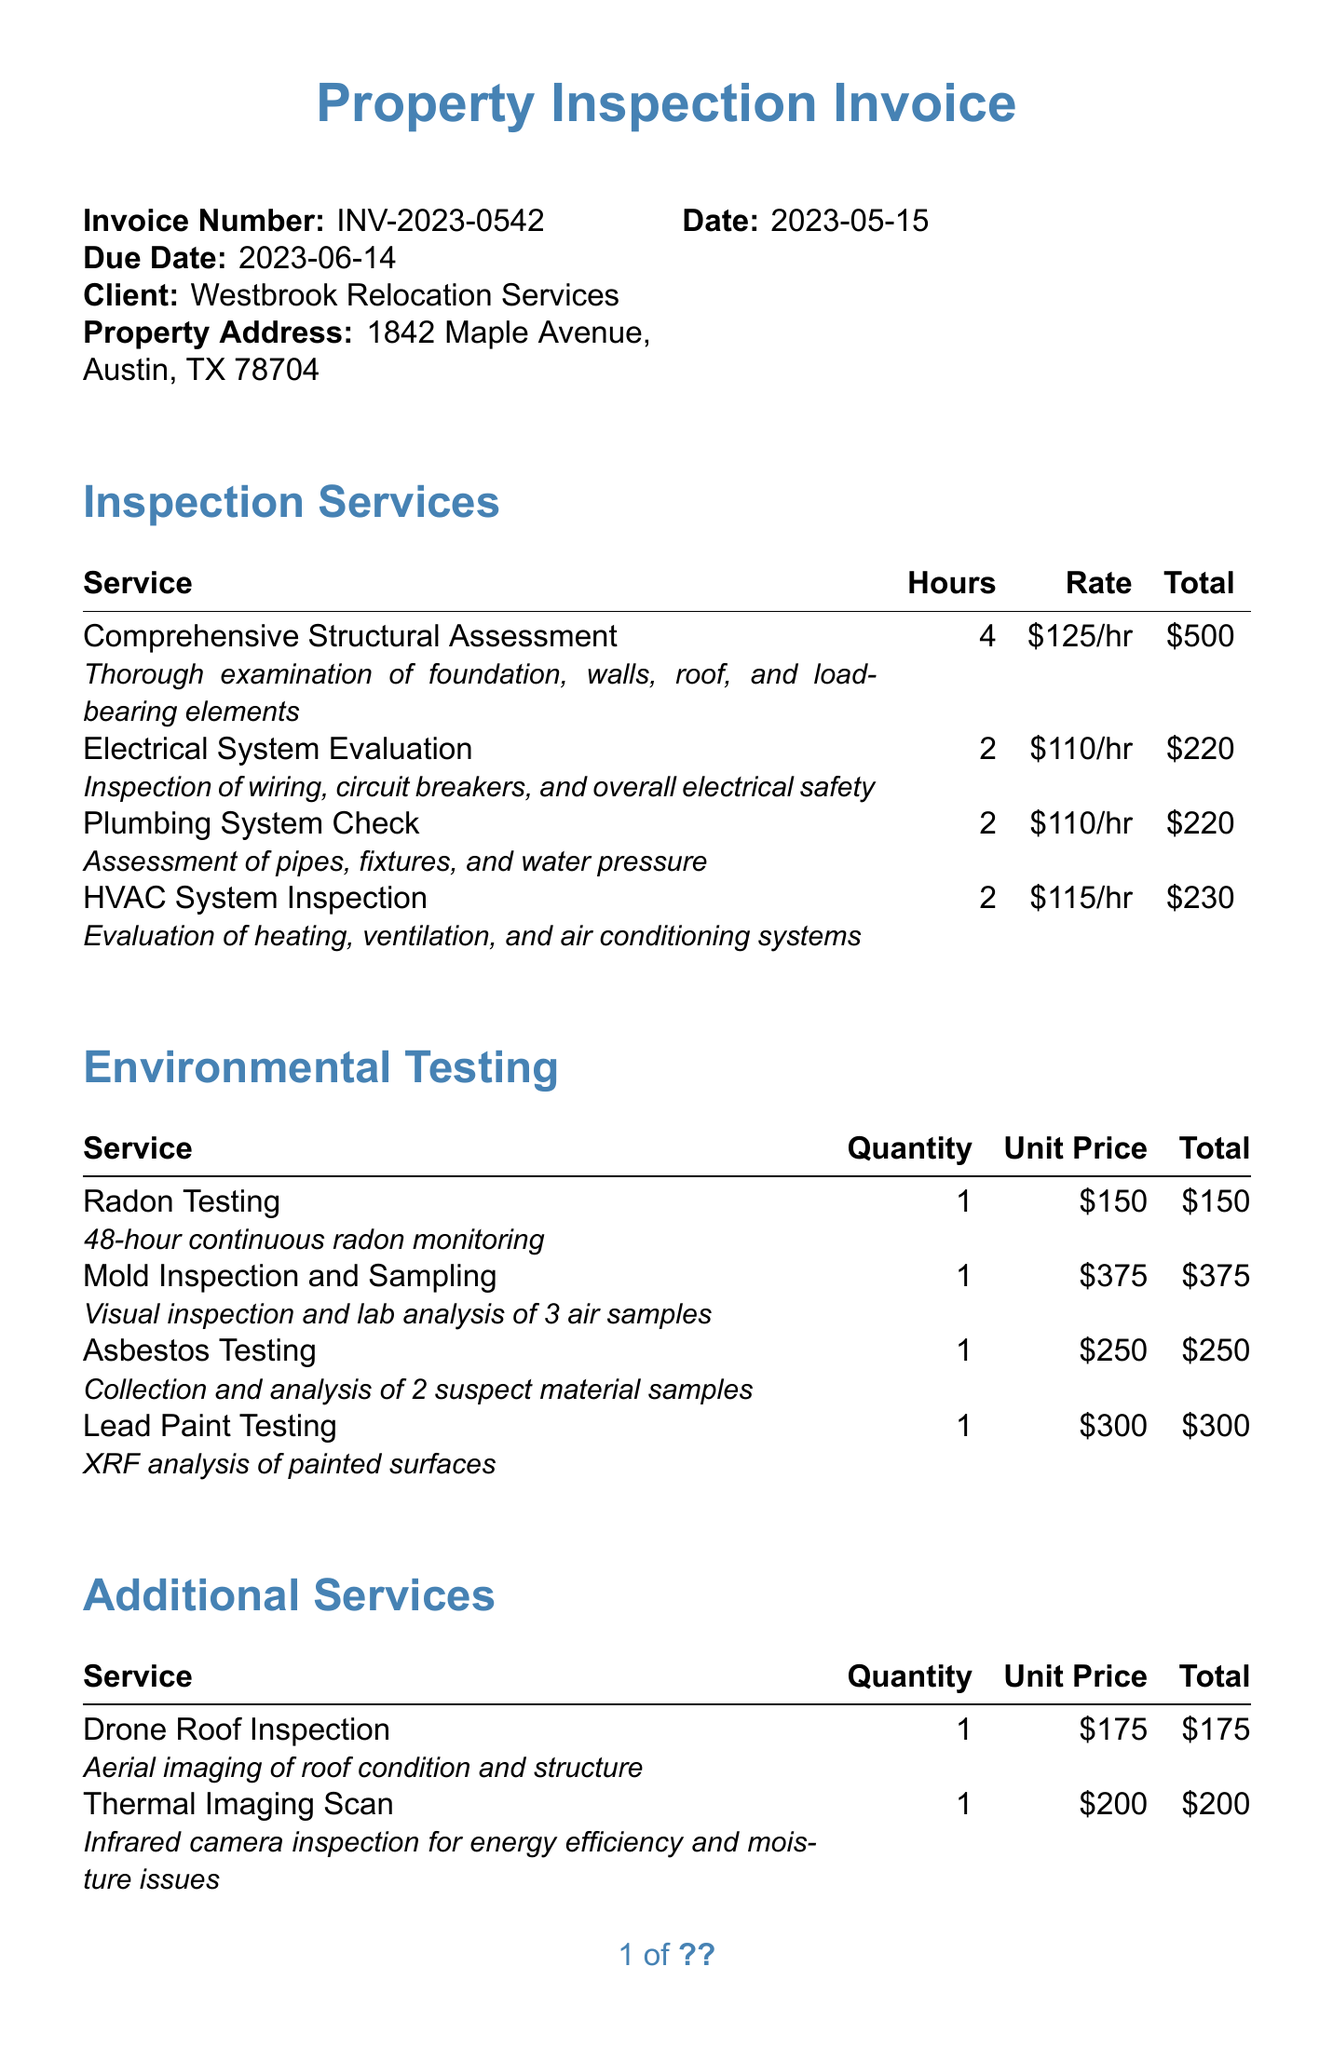What is the invoice number? The invoice number is specified in the invoice details section.
Answer: INV-2023-0542 Who is the client? The client's name is mentioned under the invoice details.
Answer: Westbrook Relocation Services What is the due date? The due date can be found in the invoice details section.
Answer: 2023-06-14 How many hours were spent on the Comprehensive Structural Assessment? The number of hours for this service is listed in the inspection services section.
Answer: 4 What is the total for Mold Inspection and Sampling? The total for Mold Inspection and Sampling is stated under the environmental testing section.
Answer: 375 What is the subtotal of the invoice? The subtotal is detailed in the summary section of the invoice.
Answer: 2620 What is the tax rate applied? The tax rate is presented in the summary section of the invoice.
Answer: 8.25% What payment terms are specified? Payment terms are outlined at the end of the document.
Answer: Net 30 Which service includes thermal imaging? This service is listed under the additional services section of the invoice.
Answer: Thermal Imaging Scan 